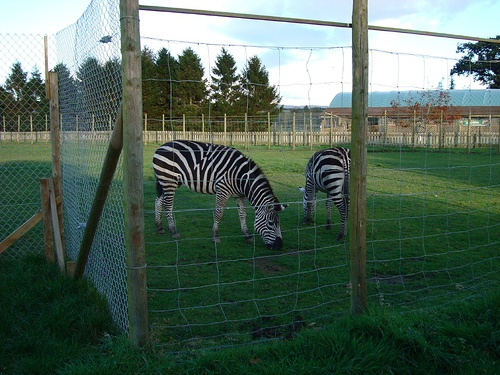Describe the objects in this image and their specific colors. I can see zebra in lightblue, black, gray, darkgray, and purple tones and zebra in lightblue, black, gray, purple, and darkgray tones in this image. 